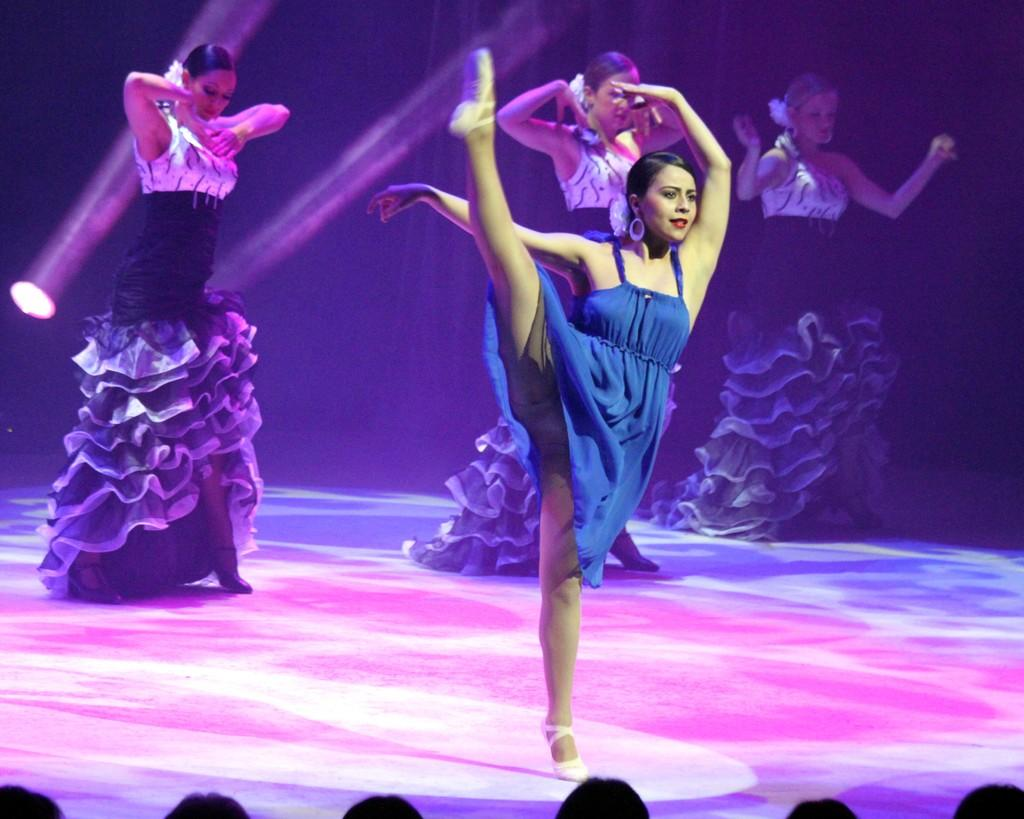How many people are in the image? There are four women in the image. What are the women doing in the image? The women are dancing. Can you describe any specific lighting in the image? There is a focus light on the left side of the image, and light rays are visible. What type of silver kite can be seen flying over the mountain in the image? There is no silver kite or mountain present in the image. 